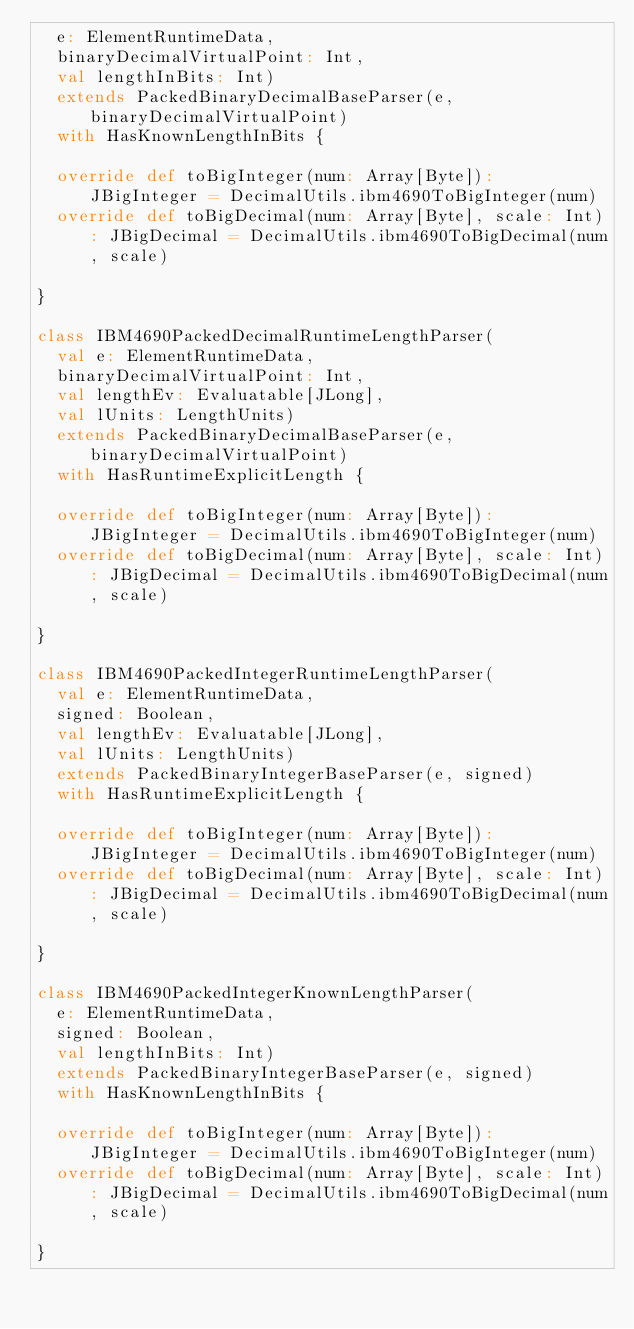Convert code to text. <code><loc_0><loc_0><loc_500><loc_500><_Scala_>  e: ElementRuntimeData,
  binaryDecimalVirtualPoint: Int,
  val lengthInBits: Int)
  extends PackedBinaryDecimalBaseParser(e, binaryDecimalVirtualPoint)
  with HasKnownLengthInBits {

  override def toBigInteger(num: Array[Byte]): JBigInteger = DecimalUtils.ibm4690ToBigInteger(num)
  override def toBigDecimal(num: Array[Byte], scale: Int): JBigDecimal = DecimalUtils.ibm4690ToBigDecimal(num, scale)

}

class IBM4690PackedDecimalRuntimeLengthParser(
  val e: ElementRuntimeData,
  binaryDecimalVirtualPoint: Int,
  val lengthEv: Evaluatable[JLong],
  val lUnits: LengthUnits)
  extends PackedBinaryDecimalBaseParser(e, binaryDecimalVirtualPoint)
  with HasRuntimeExplicitLength {

  override def toBigInteger(num: Array[Byte]): JBigInteger = DecimalUtils.ibm4690ToBigInteger(num)
  override def toBigDecimal(num: Array[Byte], scale: Int): JBigDecimal = DecimalUtils.ibm4690ToBigDecimal(num, scale)

}

class IBM4690PackedIntegerRuntimeLengthParser(
  val e: ElementRuntimeData,
  signed: Boolean,
  val lengthEv: Evaluatable[JLong],
  val lUnits: LengthUnits)
  extends PackedBinaryIntegerBaseParser(e, signed)
  with HasRuntimeExplicitLength {

  override def toBigInteger(num: Array[Byte]): JBigInteger = DecimalUtils.ibm4690ToBigInteger(num)
  override def toBigDecimal(num: Array[Byte], scale: Int): JBigDecimal = DecimalUtils.ibm4690ToBigDecimal(num, scale)

}

class IBM4690PackedIntegerKnownLengthParser(
  e: ElementRuntimeData,
  signed: Boolean,
  val lengthInBits: Int)
  extends PackedBinaryIntegerBaseParser(e, signed)
  with HasKnownLengthInBits {

  override def toBigInteger(num: Array[Byte]): JBigInteger = DecimalUtils.ibm4690ToBigInteger(num)
  override def toBigDecimal(num: Array[Byte], scale: Int): JBigDecimal = DecimalUtils.ibm4690ToBigDecimal(num, scale)

}
</code> 